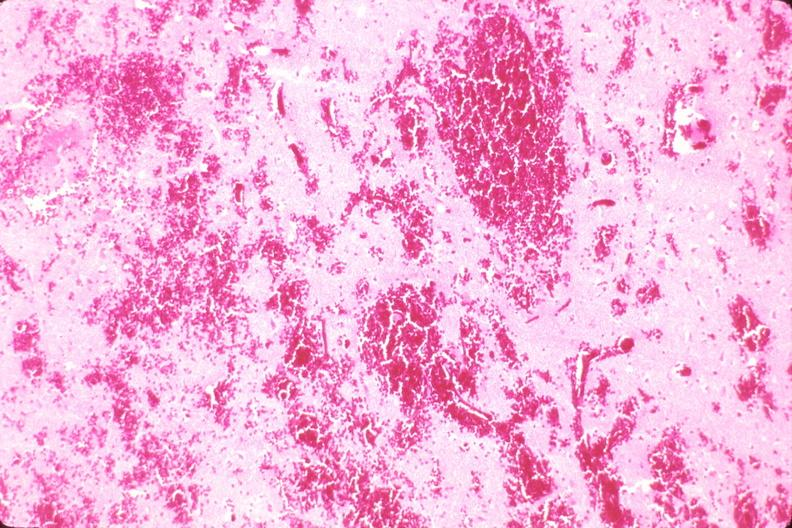s nervous present?
Answer the question using a single word or phrase. Yes 